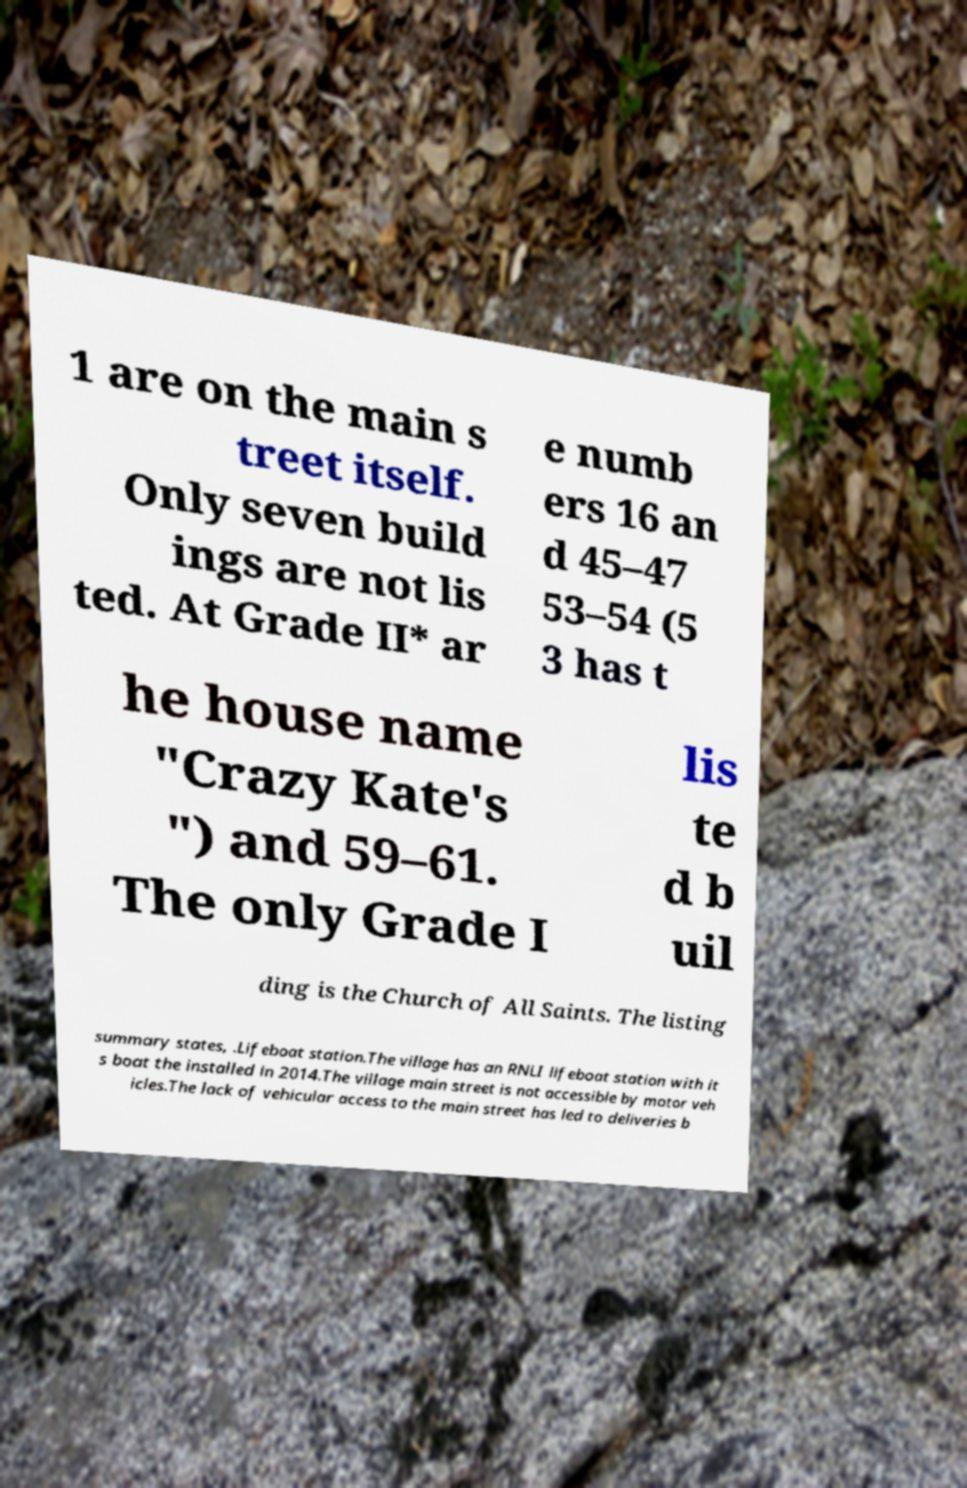Please read and relay the text visible in this image. What does it say? 1 are on the main s treet itself. Only seven build ings are not lis ted. At Grade II* ar e numb ers 16 an d 45–47 53–54 (5 3 has t he house name "Crazy Kate's ") and 59–61. The only Grade I lis te d b uil ding is the Church of All Saints. The listing summary states, .Lifeboat station.The village has an RNLI lifeboat station with it s boat the installed in 2014.The village main street is not accessible by motor veh icles.The lack of vehicular access to the main street has led to deliveries b 